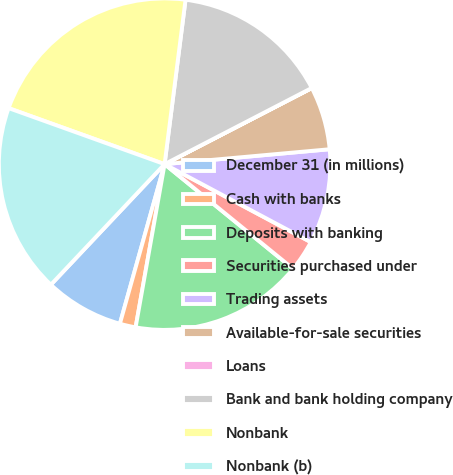Convert chart. <chart><loc_0><loc_0><loc_500><loc_500><pie_chart><fcel>December 31 (in millions)<fcel>Cash with banks<fcel>Deposits with banking<fcel>Securities purchased under<fcel>Trading assets<fcel>Available-for-sale securities<fcel>Loans<fcel>Bank and bank holding company<fcel>Nonbank<fcel>Nonbank (b)<nl><fcel>7.69%<fcel>1.55%<fcel>16.92%<fcel>3.08%<fcel>9.23%<fcel>6.16%<fcel>0.01%<fcel>15.38%<fcel>21.53%<fcel>18.45%<nl></chart> 